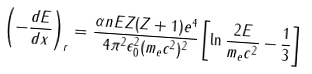<formula> <loc_0><loc_0><loc_500><loc_500>\left ( - \frac { d E } { d x } \right ) _ { r } = \frac { \alpha n E Z ( Z + 1 ) e ^ { 4 } } { 4 \pi ^ { 2 } \epsilon _ { 0 } ^ { 2 } ( m _ { e } c ^ { 2 } ) ^ { 2 } } \left [ \ln \frac { 2 E } { m _ { e } c ^ { 2 } } - \frac { 1 } { 3 } \right ]</formula> 